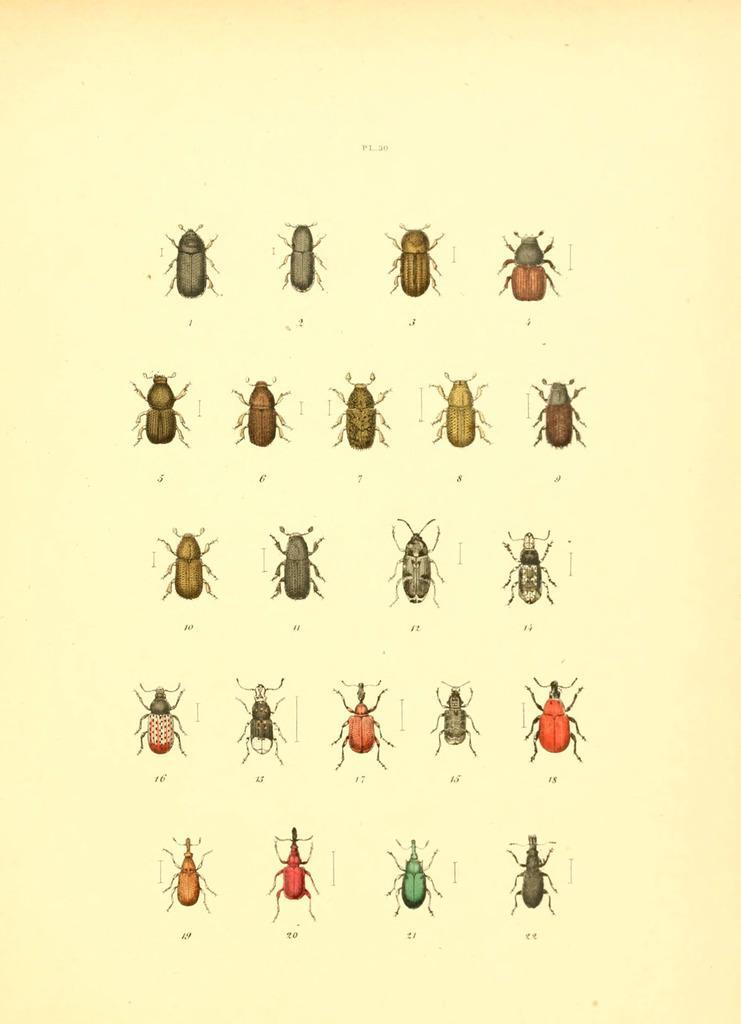Describe this image in one or two sentences. In the image there are pictures of insects. 